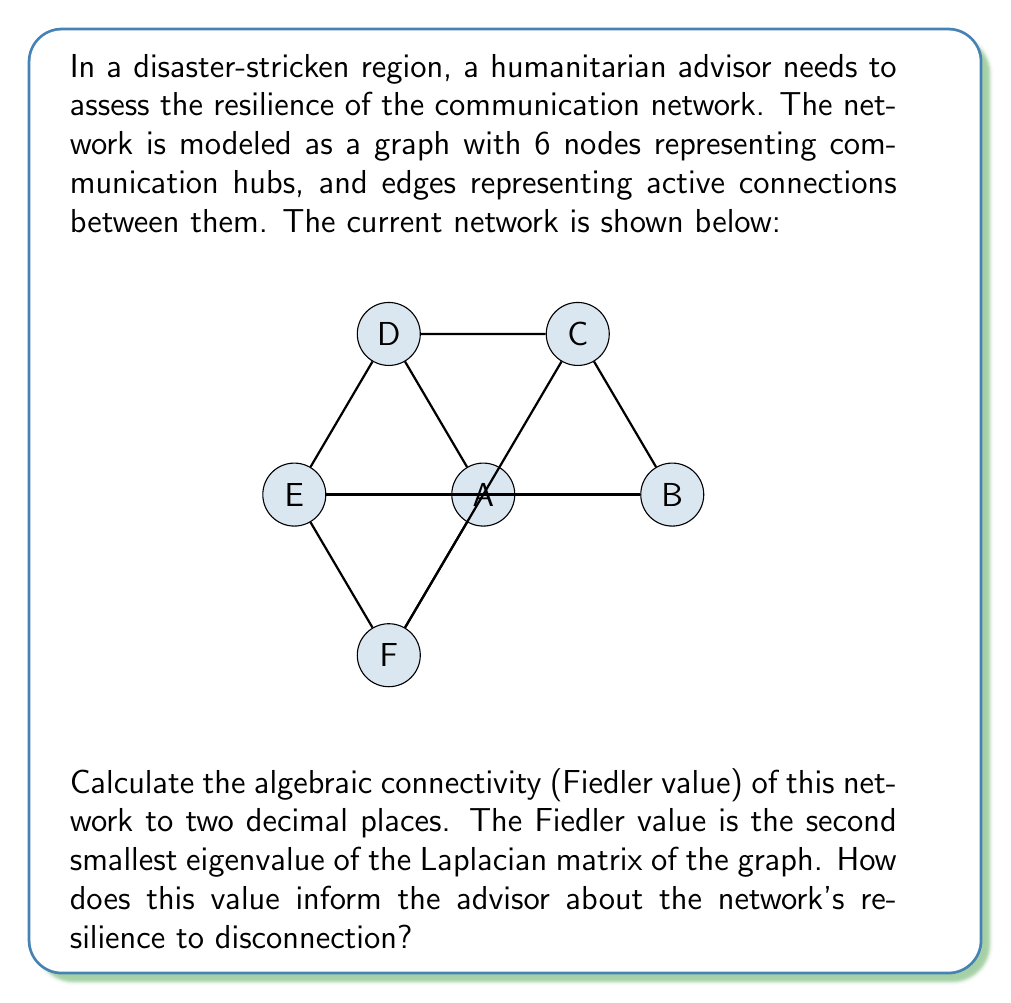Help me with this question. To solve this problem, we'll follow these steps:

1) First, construct the adjacency matrix A of the graph:
   $$A = \begin{bmatrix}
   0 & 1 & 0 & 1 & 0 & 1 \\
   1 & 0 & 1 & 0 & 1 & 0 \\
   0 & 1 & 0 & 1 & 0 & 1 \\
   1 & 0 & 1 & 0 & 1 & 0 \\
   0 & 1 & 0 & 1 & 0 & 1 \\
   1 & 0 & 1 & 0 & 1 & 0
   \end{bmatrix}$$

2) Calculate the degree matrix D:
   $$D = \begin{bmatrix}
   3 & 0 & 0 & 0 & 0 & 0 \\
   0 & 3 & 0 & 0 & 0 & 0 \\
   0 & 0 & 3 & 0 & 0 & 0 \\
   0 & 0 & 0 & 3 & 0 & 0 \\
   0 & 0 & 0 & 0 & 3 & 0 \\
   0 & 0 & 0 & 0 & 0 & 3
   \end{bmatrix}$$

3) Compute the Laplacian matrix L = D - A:
   $$L = \begin{bmatrix}
   3 & -1 & 0 & -1 & 0 & -1 \\
   -1 & 3 & -1 & 0 & -1 & 0 \\
   0 & -1 & 3 & -1 & 0 & -1 \\
   -1 & 0 & -1 & 3 & -1 & 0 \\
   0 & -1 & 0 & -1 & 3 & -1 \\
   -1 & 0 & -1 & 0 & -1 & 3
   \end{bmatrix}$$

4) Calculate the eigenvalues of L. Using a computer algebra system, we get:
   $\lambda_1 = 0$
   $\lambda_2 = 1$
   $\lambda_3 = 3$
   $\lambda_4 = 3$
   $\lambda_5 = 4$
   $\lambda_6 = 5$

5) The Fiedler value is the second smallest eigenvalue, which is 1.00.

The Fiedler value provides information about the network's connectivity and resilience:

- A higher Fiedler value indicates better connectivity and more resilience against disconnection.
- The value of 1.00 suggests moderate connectivity. The network is connected but not highly robust.
- As an advisor, this indicates that while the network is functional, it could be vulnerable to disconnection if key nodes or edges fail.
- Efforts to improve resilience could focus on adding redundant connections or strengthening existing ones.
Answer: 1.00; moderate connectivity, vulnerable to strategic disconnections 